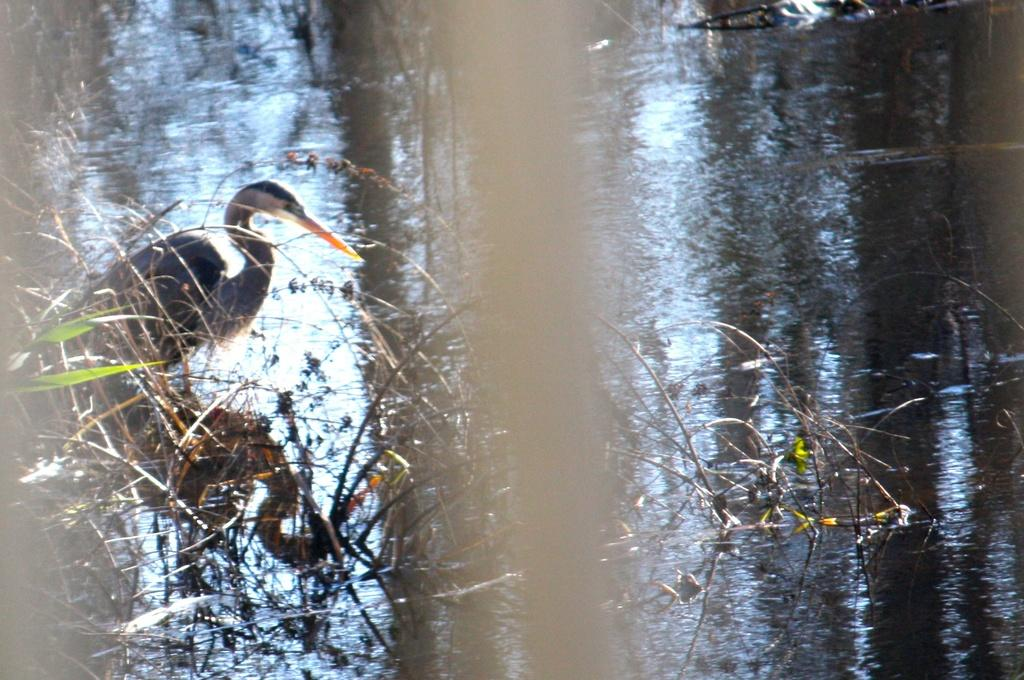What type of animal is in the image? There is a bird in the image. Can you describe the bird's appearance? The bird is white and black in color. What else can be seen in the image besides the bird? There is water and plants visible in the image. What letters can be seen on the stove in the image? There is no stove present in the image, and therefore no letters can be seen on it. 